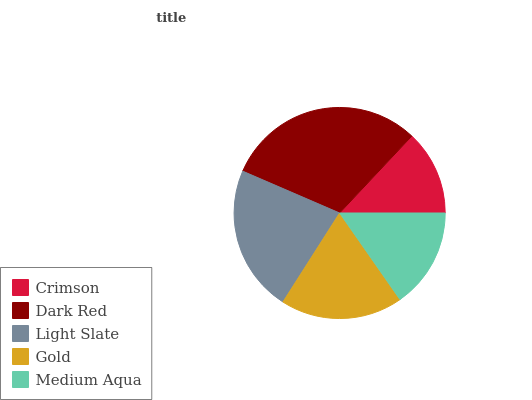Is Crimson the minimum?
Answer yes or no. Yes. Is Dark Red the maximum?
Answer yes or no. Yes. Is Light Slate the minimum?
Answer yes or no. No. Is Light Slate the maximum?
Answer yes or no. No. Is Dark Red greater than Light Slate?
Answer yes or no. Yes. Is Light Slate less than Dark Red?
Answer yes or no. Yes. Is Light Slate greater than Dark Red?
Answer yes or no. No. Is Dark Red less than Light Slate?
Answer yes or no. No. Is Gold the high median?
Answer yes or no. Yes. Is Gold the low median?
Answer yes or no. Yes. Is Dark Red the high median?
Answer yes or no. No. Is Light Slate the low median?
Answer yes or no. No. 